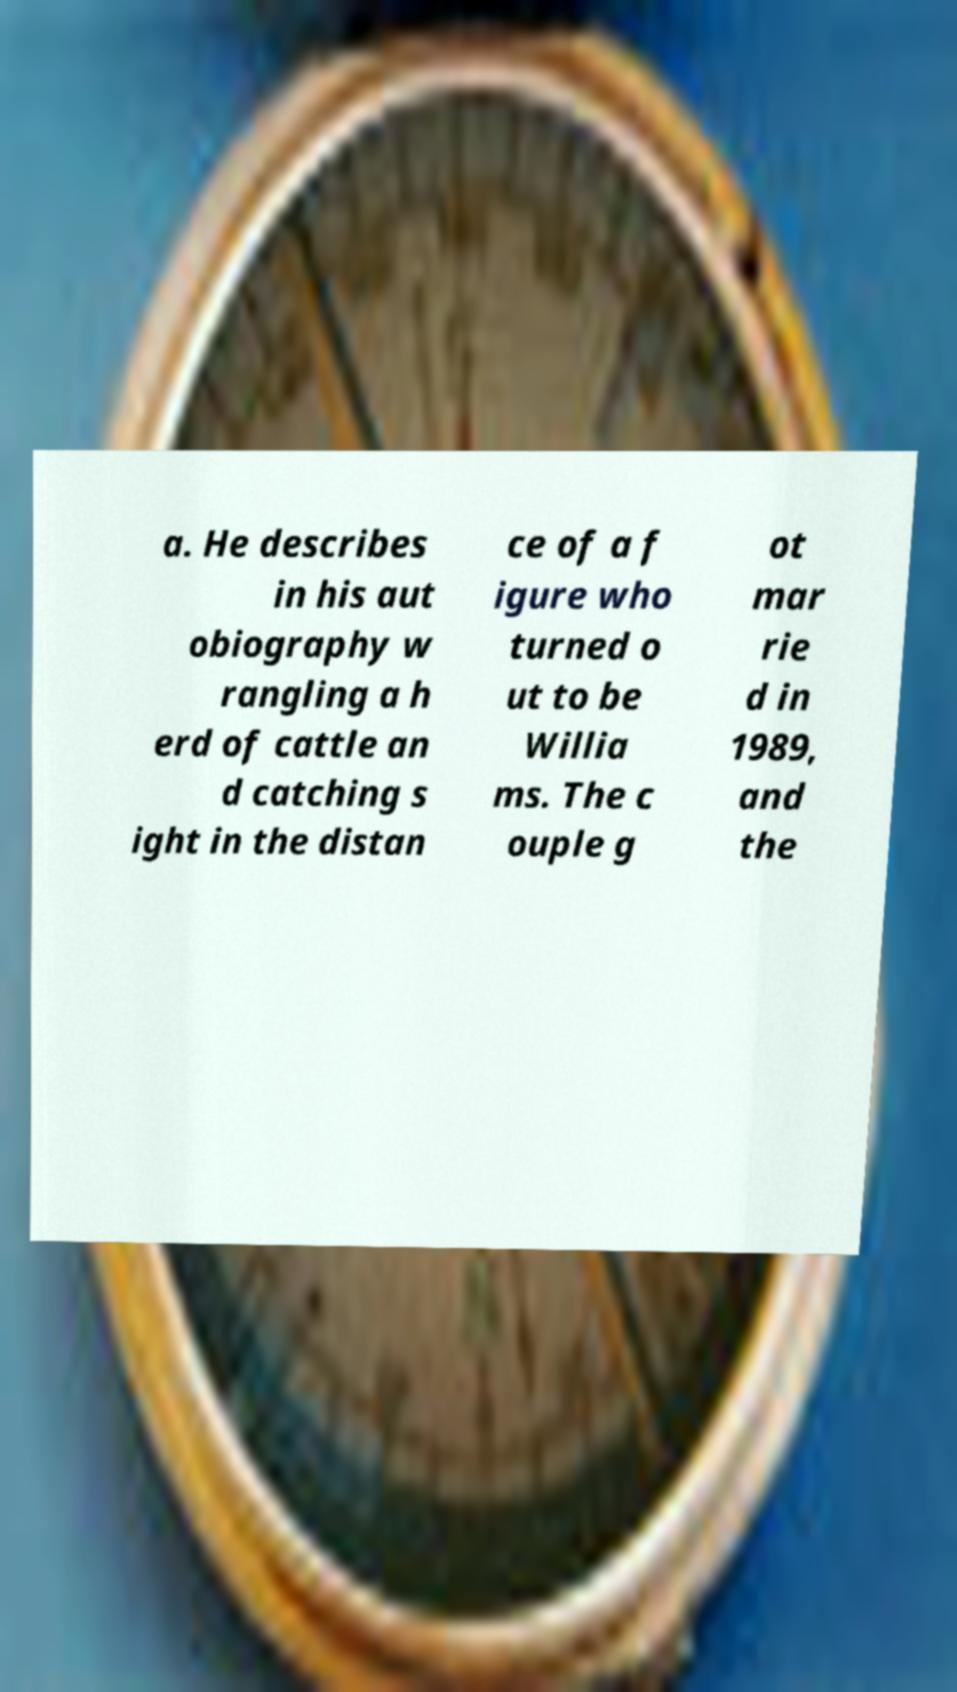Could you assist in decoding the text presented in this image and type it out clearly? a. He describes in his aut obiography w rangling a h erd of cattle an d catching s ight in the distan ce of a f igure who turned o ut to be Willia ms. The c ouple g ot mar rie d in 1989, and the 